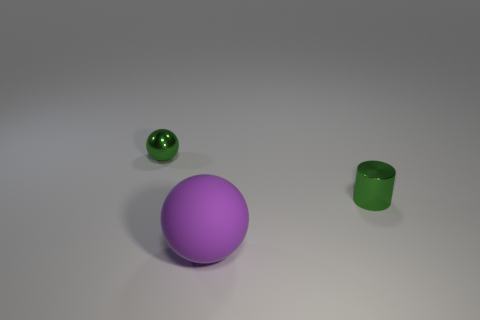Add 2 tiny gray things. How many objects exist? 5 Subtract all spheres. How many objects are left? 1 Add 3 small spheres. How many small spheres exist? 4 Subtract 0 red balls. How many objects are left? 3 Subtract all brown cylinders. Subtract all purple balls. How many objects are left? 2 Add 1 purple objects. How many purple objects are left? 2 